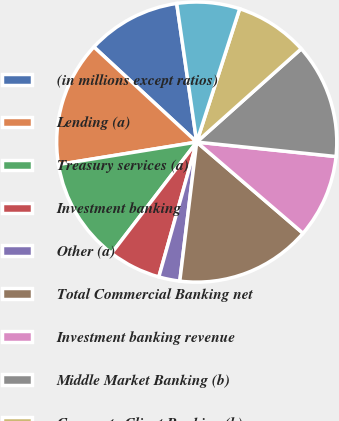Convert chart to OTSL. <chart><loc_0><loc_0><loc_500><loc_500><pie_chart><fcel>(in millions except ratios)<fcel>Lending (a)<fcel>Treasury services (a)<fcel>Investment banking<fcel>Other (a)<fcel>Total Commercial Banking net<fcel>Investment banking revenue<fcel>Middle Market Banking (b)<fcel>Corporate Client Banking (b)<fcel>Commercial Term Lending<nl><fcel>10.84%<fcel>14.44%<fcel>12.04%<fcel>6.04%<fcel>2.43%<fcel>15.64%<fcel>9.64%<fcel>13.24%<fcel>8.44%<fcel>7.24%<nl></chart> 